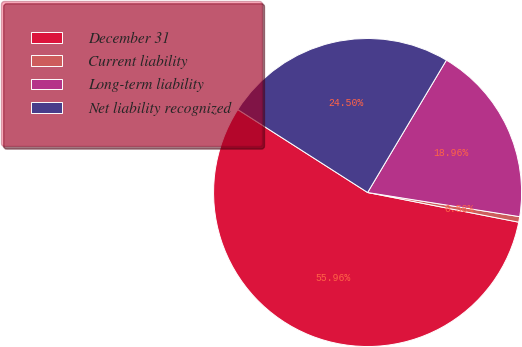Convert chart to OTSL. <chart><loc_0><loc_0><loc_500><loc_500><pie_chart><fcel>December 31<fcel>Current liability<fcel>Long-term liability<fcel>Net liability recognized<nl><fcel>55.96%<fcel>0.58%<fcel>18.96%<fcel>24.5%<nl></chart> 